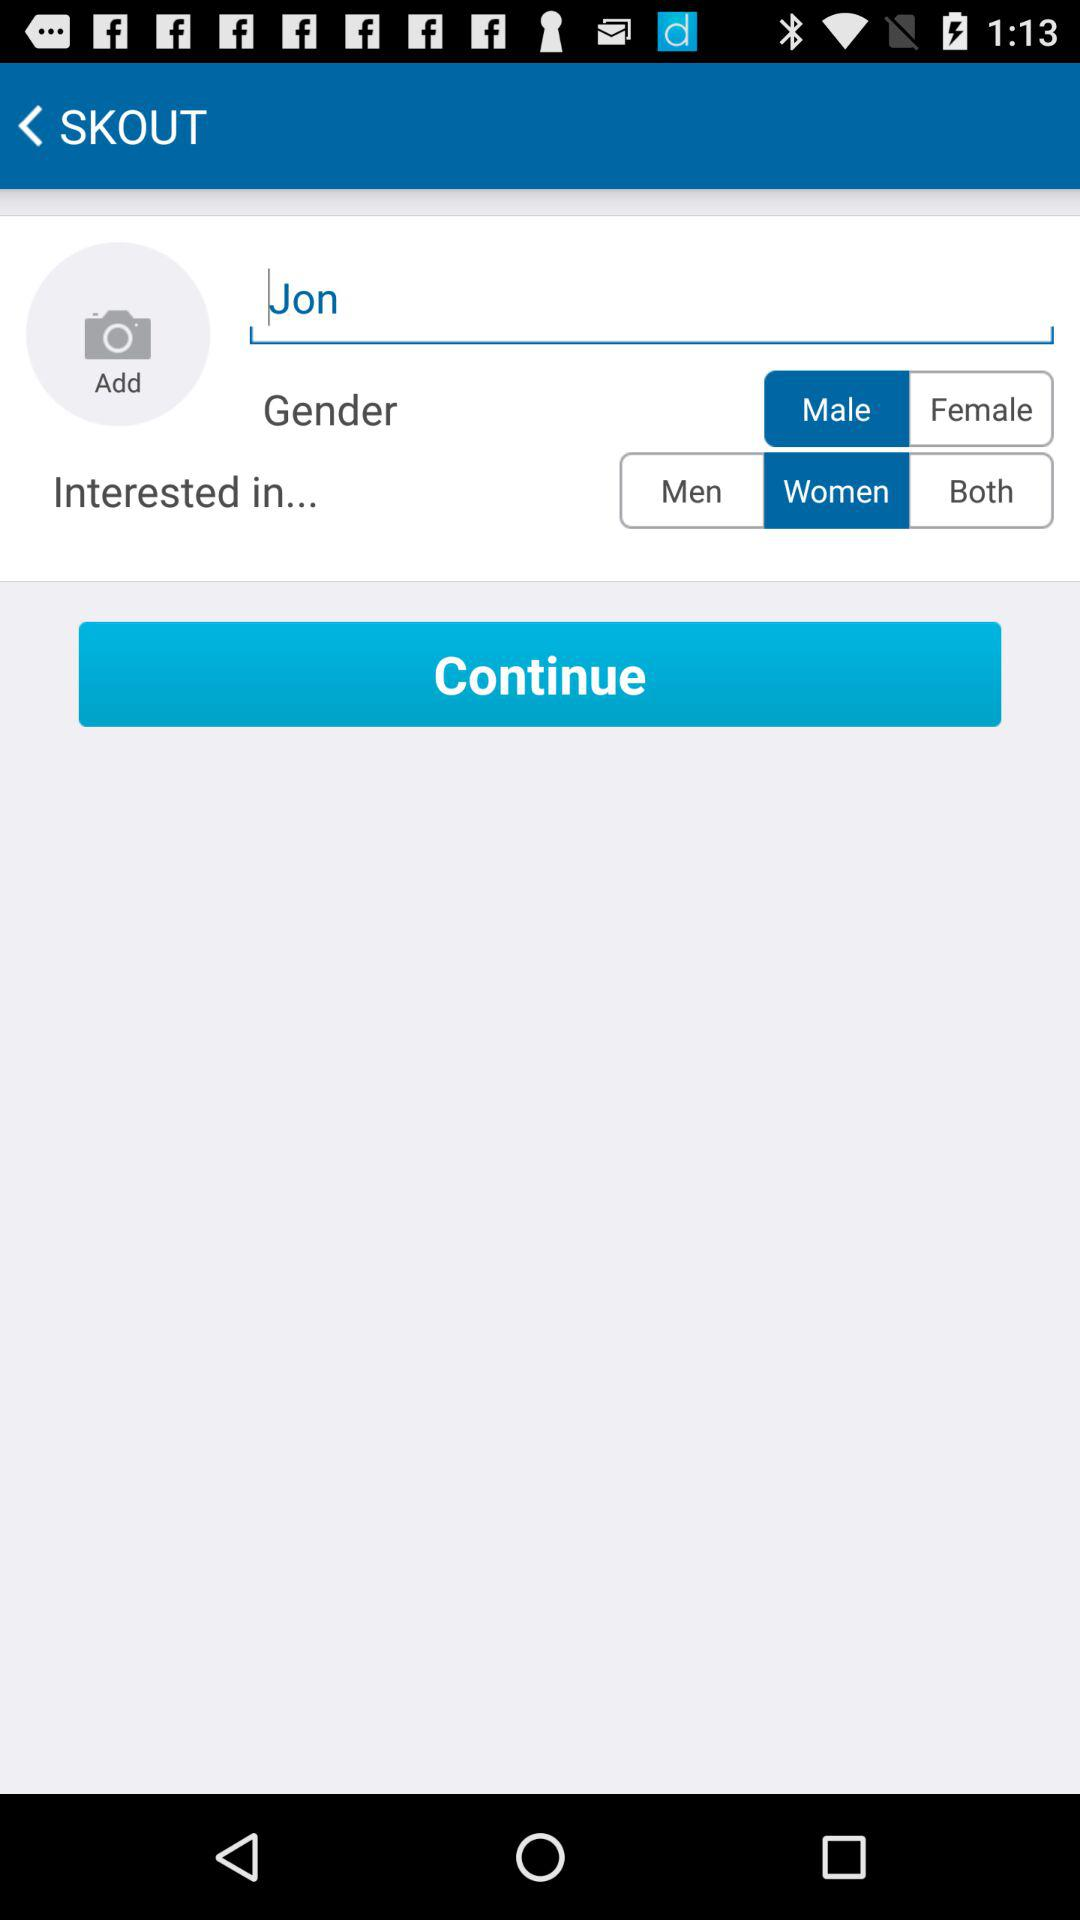How tall is Jon?
When the provided information is insufficient, respond with <no answer>. <no answer> 